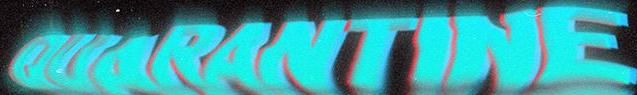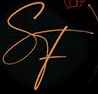Read the text content from these images in order, separated by a semicolon. OUARANTINE; SF 